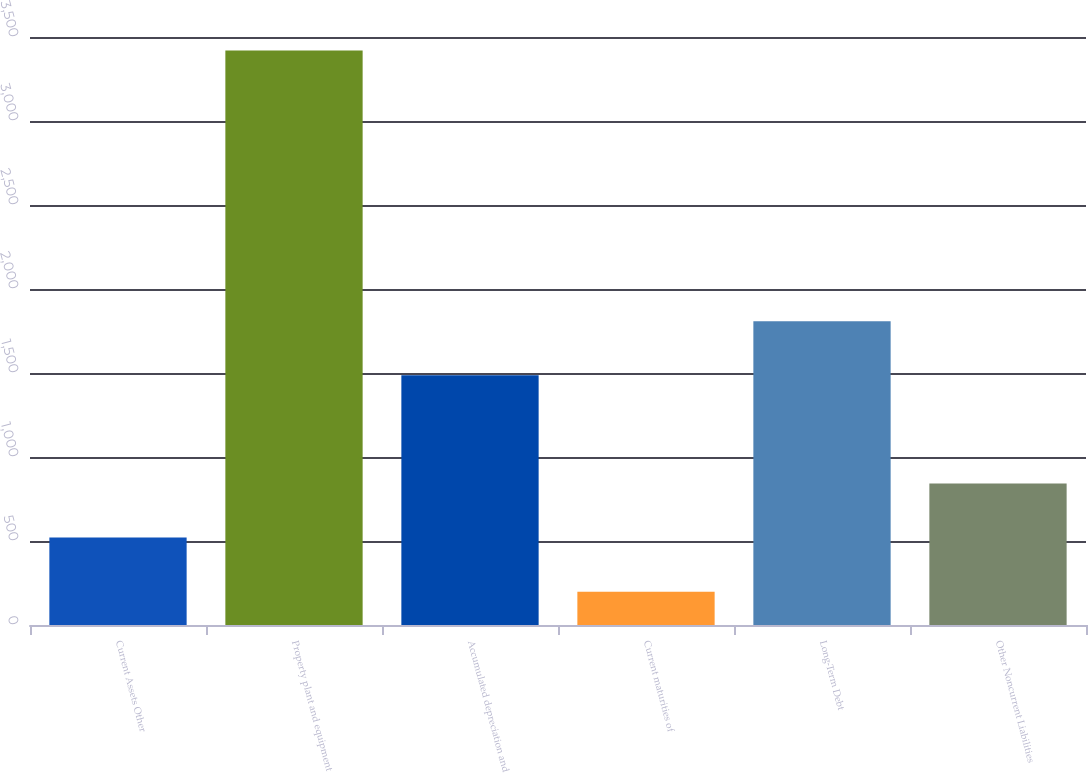Convert chart to OTSL. <chart><loc_0><loc_0><loc_500><loc_500><bar_chart><fcel>Current Assets Other<fcel>Property plant and equipment<fcel>Accumulated depreciation and<fcel>Current maturities of<fcel>Long-Term Debt<fcel>Other Noncurrent Liabilities<nl><fcel>520.1<fcel>3419<fcel>1486.4<fcel>198<fcel>1808.5<fcel>842.2<nl></chart> 